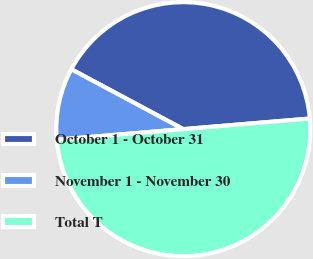Convert chart to OTSL. <chart><loc_0><loc_0><loc_500><loc_500><pie_chart><fcel>October 1 - October 31<fcel>November 1 - November 30<fcel>Total T<nl><fcel>40.85%<fcel>9.15%<fcel>50.0%<nl></chart> 